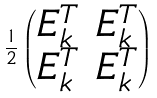<formula> <loc_0><loc_0><loc_500><loc_500>\frac { 1 } { 2 } \begin{pmatrix} E _ { k } ^ { T } & E _ { k } ^ { T } \\ E _ { k } ^ { T } & E _ { k } ^ { T } \\ \end{pmatrix}</formula> 